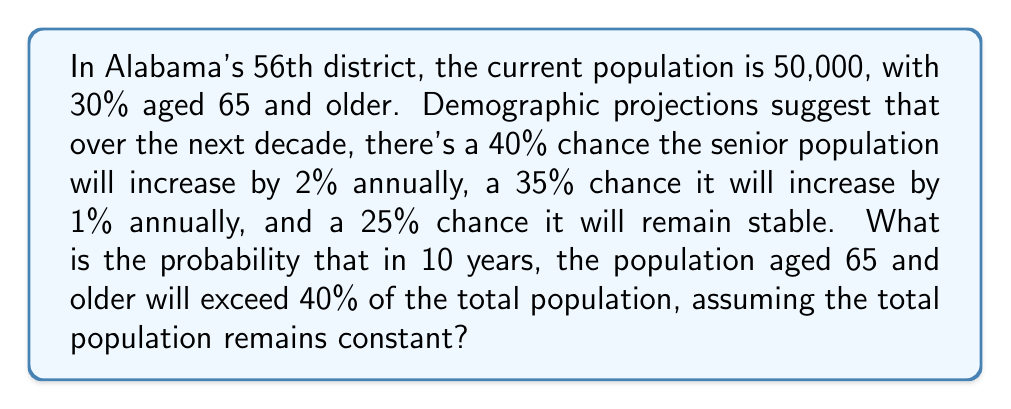Could you help me with this problem? Let's approach this step-by-step:

1) First, calculate the current number of seniors:
   $0.30 \times 50,000 = 15,000$ seniors

2) Now, let's consider each scenario:

   a) 2% annual increase for 10 years:
      $15,000 \times (1.02)^{10} \approx 18,280$

   b) 1% annual increase for 10 years:
      $15,000 \times (1.01)^{10} \approx 16,559$

   c) No increase:
      $15,000$

3) Calculate the percentage of seniors in each scenario:

   a) $\frac{18,280}{50,000} \times 100\% \approx 36.56\%$
   b) $\frac{16,559}{50,000} \times 100\% \approx 33.12\%$
   c) $\frac{15,000}{50,000} \times 100\% = 30\%$

4) Only scenario (a) results in a percentage over 40%.

5) The probability of scenario (a) occurring is 40% or 0.4.

Therefore, the probability that the senior population will exceed 40% of the total population in 10 years is 0.4 or 40%.
Answer: 0.4 or 40% 